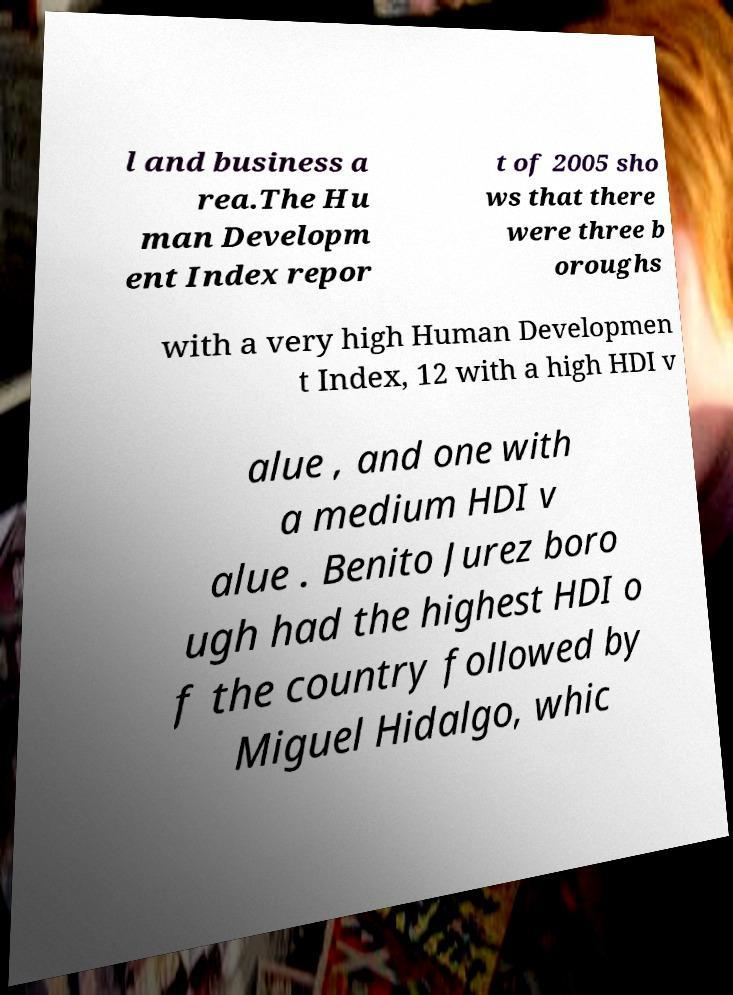There's text embedded in this image that I need extracted. Can you transcribe it verbatim? l and business a rea.The Hu man Developm ent Index repor t of 2005 sho ws that there were three b oroughs with a very high Human Developmen t Index, 12 with a high HDI v alue , and one with a medium HDI v alue . Benito Jurez boro ugh had the highest HDI o f the country followed by Miguel Hidalgo, whic 